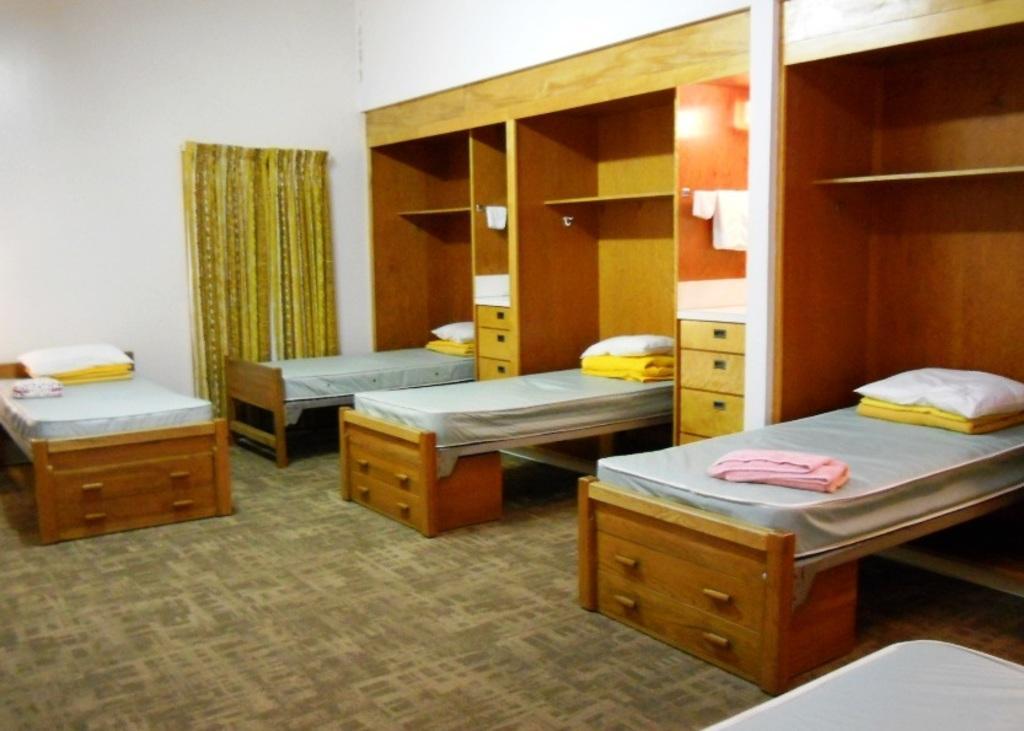How would you summarize this image in a sentence or two? There are four beds and these are the pillows. This is floor and there is a carpet. In the background there is a wall and this is curtain. And this is rack. 